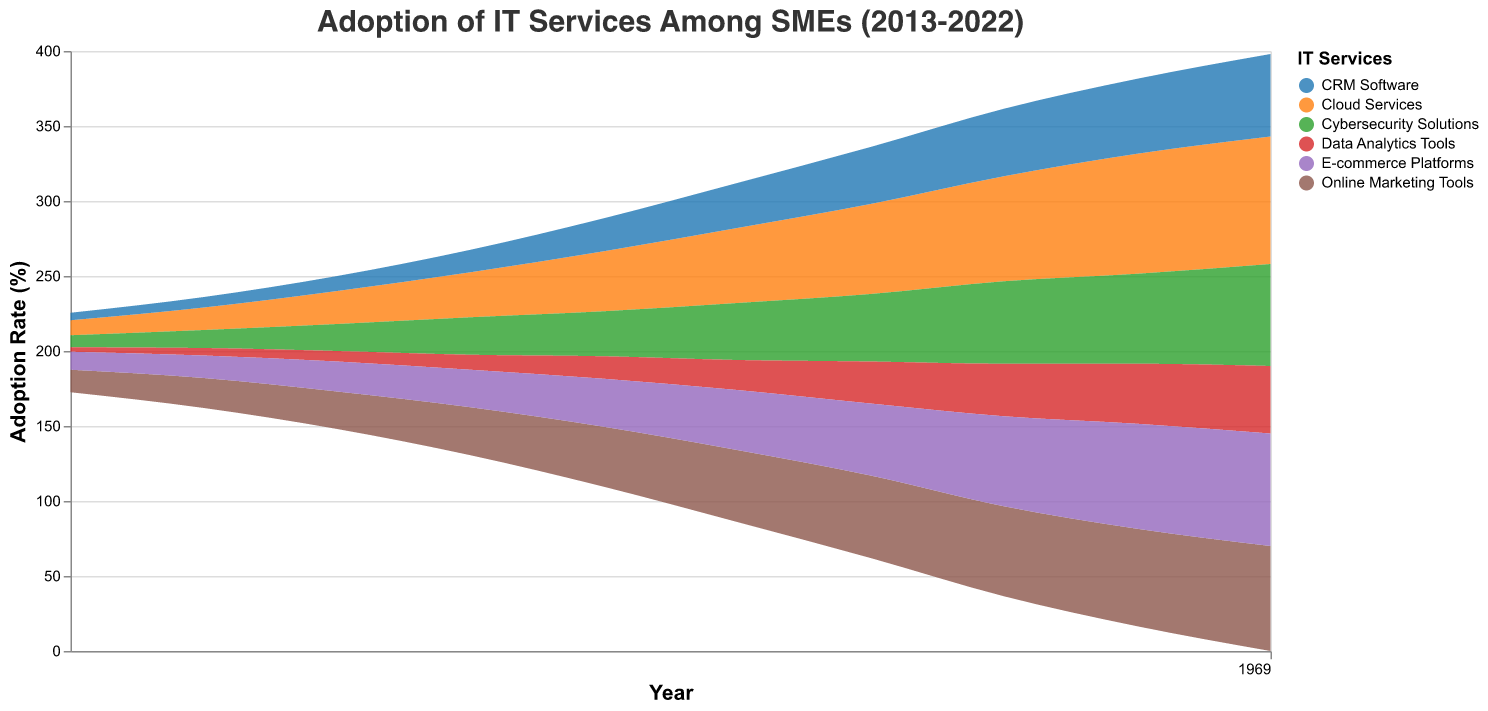What is the title of the figure? The title is displayed at the top of the figure and summarizes what the data visualizes. The title is "Adoption of IT Services Among SMEs (2013-2022)."
Answer: Adoption of IT Services Among SMEs (2013-2022) Which IT service had the highest adoption rate in 2022? Observing the height of the colored stacks in the 2022 column, Cloud Services had the highest adoption rate.
Answer: Cloud Services How has the adoption of CRM Software changed from 2013 to 2022? From 2013 to 2022, the width of the segment corresponding to CRM Software in the stack has increased, indicating a growing adoption rate. Specifically, it increased from 5% in 2013 to 55% in 2022.
Answer: Increased from 5% to 55% Among the services with an adoption rate above 50% in 2022, which service had the least adoption rate? Comparing the segments in 2022 for services above 50%, CRM Software had the lowest adoption rate at 55%.
Answer: CRM Software What is the combined adoption rate of Online Marketing Tools and E-commerce Platforms in 2018? Adding the adoption rates of Online Marketing Tools (48%) and E-commerce Platforms (40%) in 2018 gives a total adoption rate. 48% + 40% = 88%
Answer: 88% Did Cloud Services consistently have higher adoption rates than Cybersecurity Solutions throughout the decade? Comparing the height of the Cloud Services and Cybersecurity Solutions segments for each year, Cloud Services consistently had higher adoption rates.
Answer: Yes Which service experienced the largest increase in adoption rate from 2013 to 2022? By calculating the difference in adoption rates for each service from 2013 to 2022, Cloud Services experienced the largest increase (85% - 10% = 75%).
Answer: Cloud Services In which year did Data Analytics Tools see the highest adoption rate? Looking at the height of the Data Analytics Tools segment across the years, 2022 had the highest adoption rate for this service at 45%.
Answer: 2022 What is the average adoption rate of Data Analytics Tools from 2013 to 2022? Summing the adoption rates of Data Analytics Tools from each year (3+5+7+10+15+20+28+35+40+45) and dividing by 10, the average adoption rate is calculated as (208/10) = 20.8%.
Answer: 20.8% 